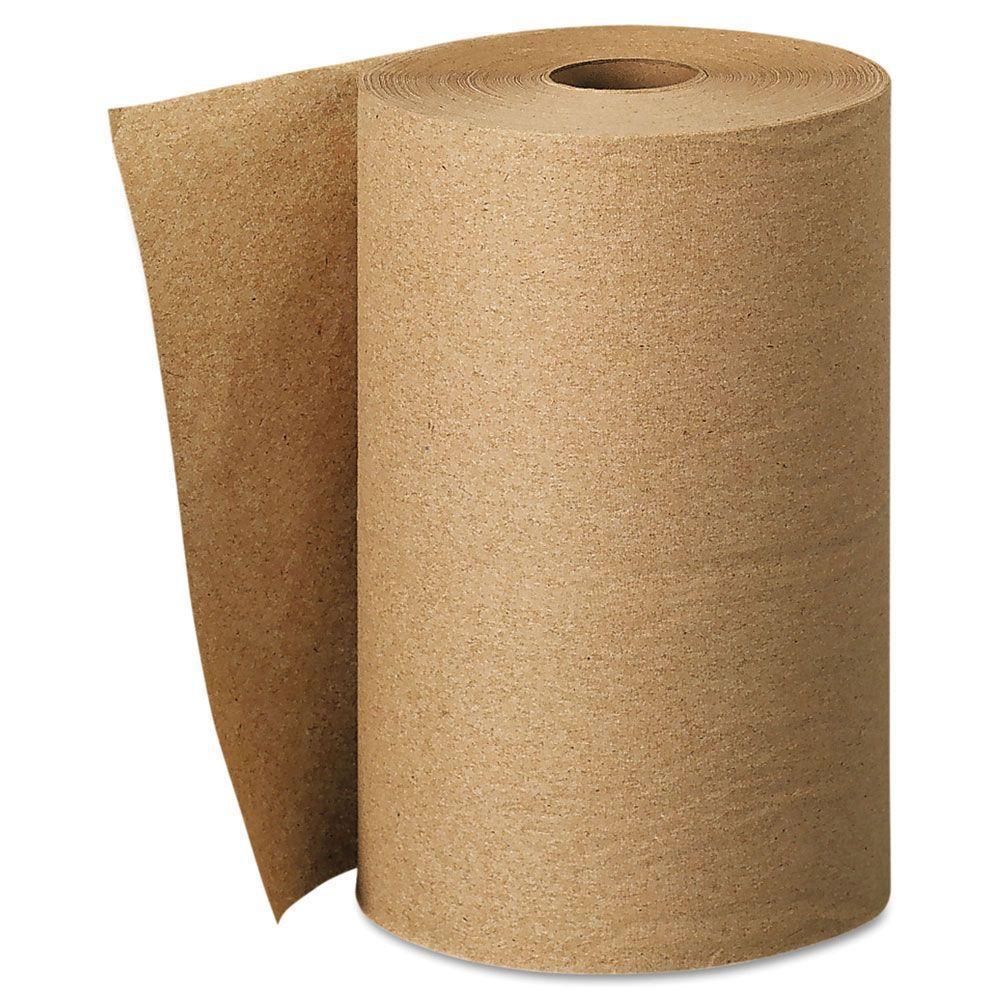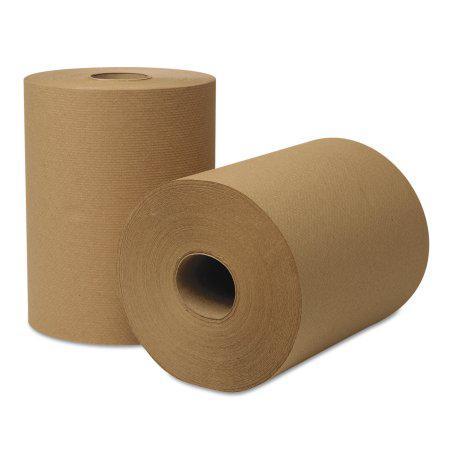The first image is the image on the left, the second image is the image on the right. Examine the images to the left and right. Is the description "The roll of brown paper in the image on the right is partially unrolled." accurate? Answer yes or no. No. The first image is the image on the left, the second image is the image on the right. For the images shown, is this caption "There are two paper towel rolls" true? Answer yes or no. No. 